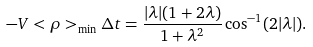<formula> <loc_0><loc_0><loc_500><loc_500>- V < \rho > _ { \min } \Delta t = \frac { | \lambda | ( 1 + 2 \lambda ) } { 1 + \lambda ^ { 2 } } \cos ^ { - 1 } ( 2 | \lambda | ) .</formula> 